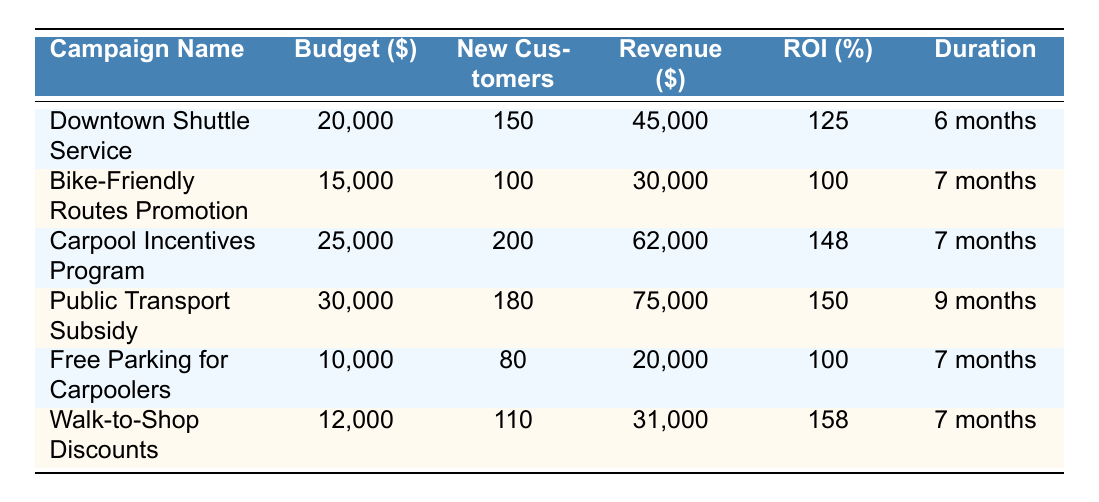What is the total budget allocated for the marketing campaigns? To find the total budget, we need to sum the budget of all campaigns listed in the table: 20000 + 15000 + 25000 + 30000 + 10000 + 12000 = 112000.
Answer: 112000 Which campaign generated the highest revenue? Looking at the revenue generated for each campaign, the Public Transport Subsidy generated the highest revenue of 75000.
Answer: Public Transport Subsidy What is the ROI of the Walk-to-Shop Discounts campaign? The ROI for the Walk-to-Shop Discounts campaign is directly listed in the table as 158%.
Answer: 158 Is the budget for the Carpool Incentives Program greater than the budget for the Downtown Shuttle Service? Comparing the budgets, the Carpool Incentives Program has a budget of 25000, which is greater than the Downtown Shuttle Service's budget of 20000.
Answer: Yes What is the average ROI of all campaigns? To calculate the average ROI, sum the ROI values: (125 + 100 + 148 + 150 + 100 + 158) = 881. Then divide by the number of campaigns (6): 881 / 6 = 146.83.
Answer: 146.83 Did the Free Parking for Carpoolers campaign have more new customers than the Bike-Friendly Routes Promotion campaign? Free Parking for Carpoolers had 80 new customers, while the Bike-Friendly Routes Promotion had 100 new customers; hence, Free Parking for Carpoolers had fewer customers.
Answer: No What is the total revenue generated by all campaigns? To find the total revenue, sum the revenue generated by each campaign: 45000 + 30000 + 62000 + 75000 + 20000 + 31000 = 263000.
Answer: 263000 Which campaign had the longest duration? The Public Transport Subsidy campaign lasted for 9 months, which is longer than the other campaigns that ranged from 6 to 7 months.
Answer: Public Transport Subsidy 